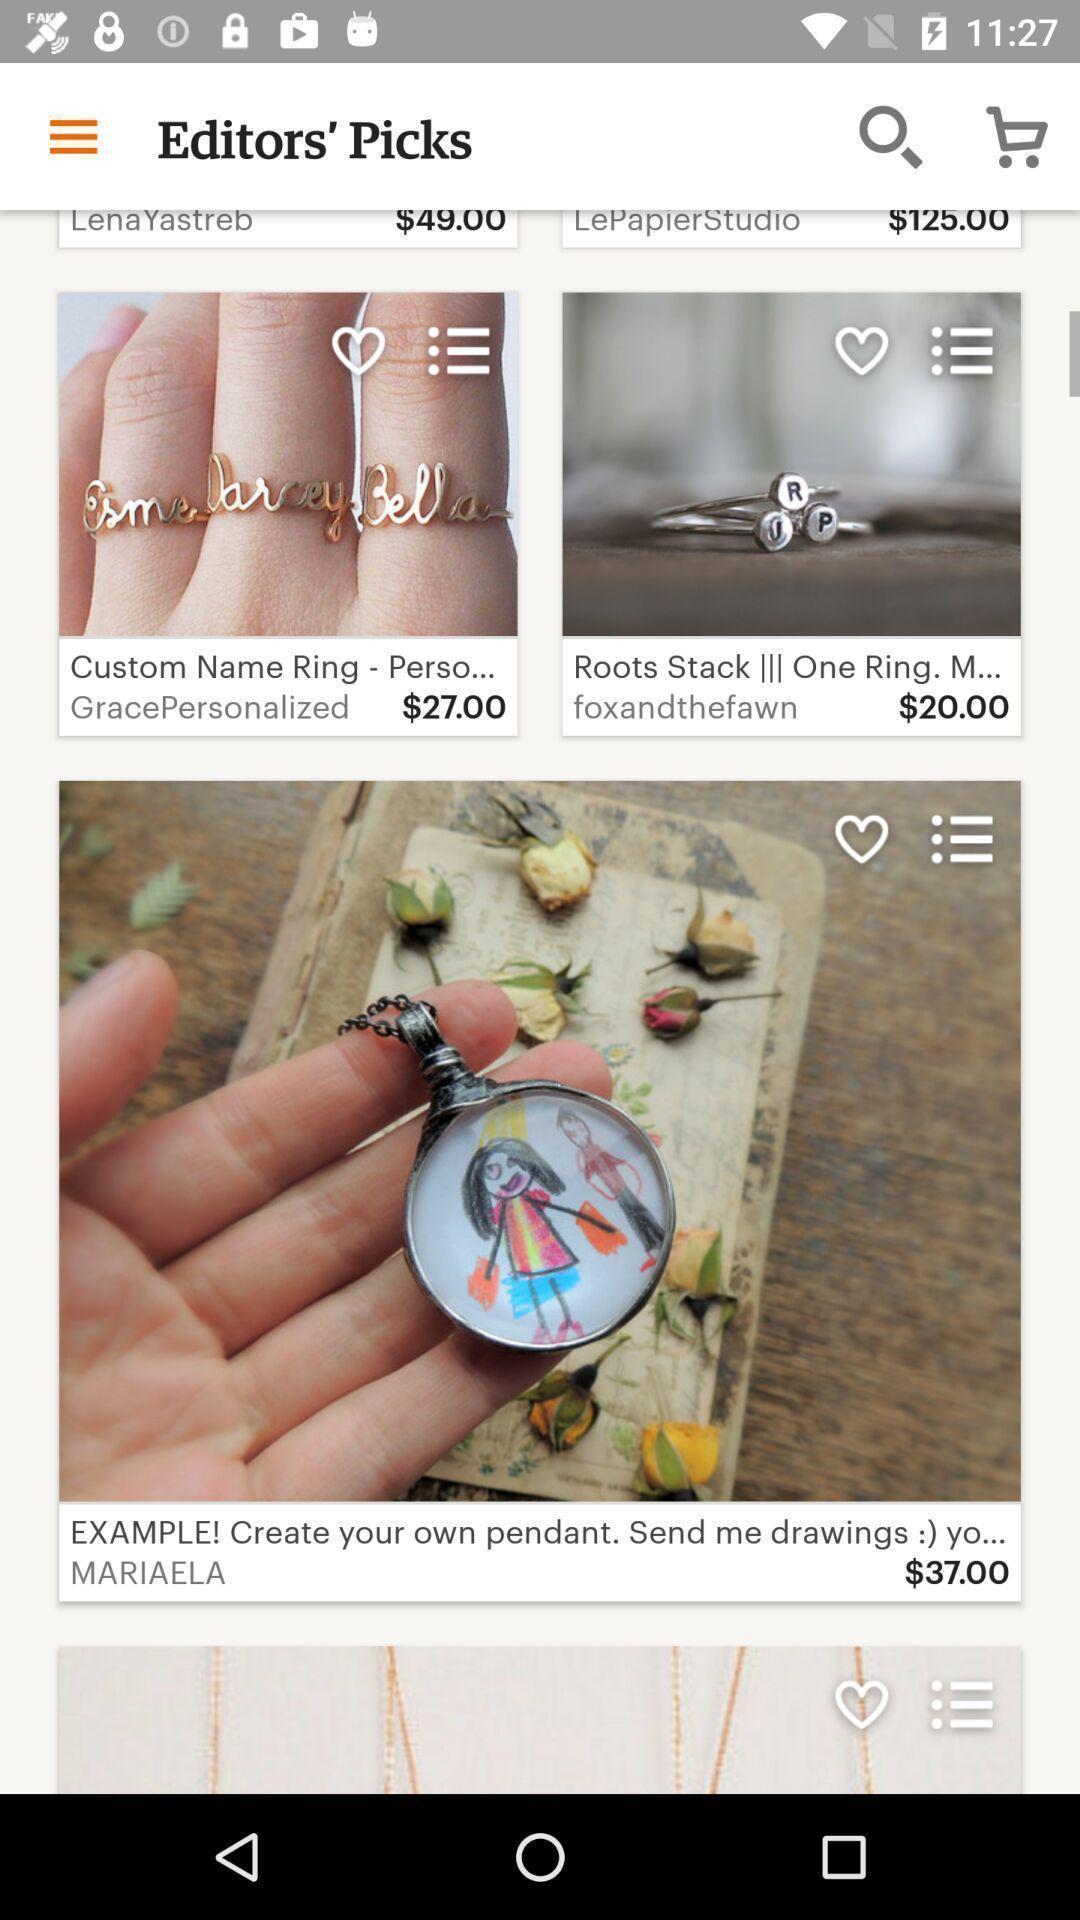Give me a summary of this screen capture. Screen shows multiple products in a shopping application. 